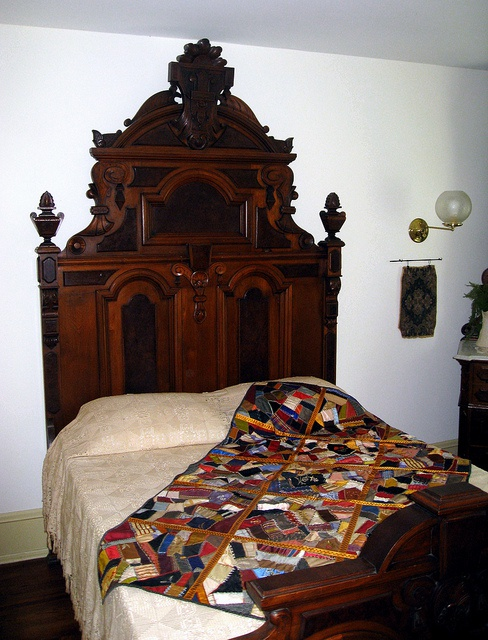Describe the objects in this image and their specific colors. I can see a bed in darkgray, black, maroon, and lightgray tones in this image. 